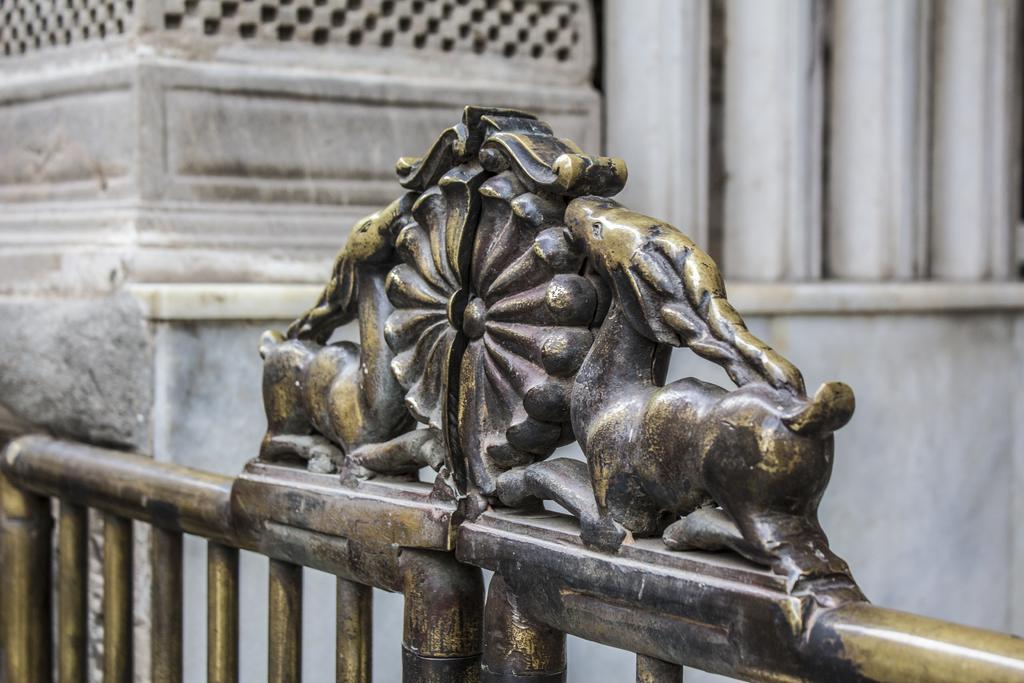What is the color of the building wall in the image? The building wall in the image is white. What is located in front of the building wall? There is an iron gate in front of the wall. What type of skirt is hanging on the iron gate in the image? There is no skirt present in the image; it features a white building wall and an iron gate. 